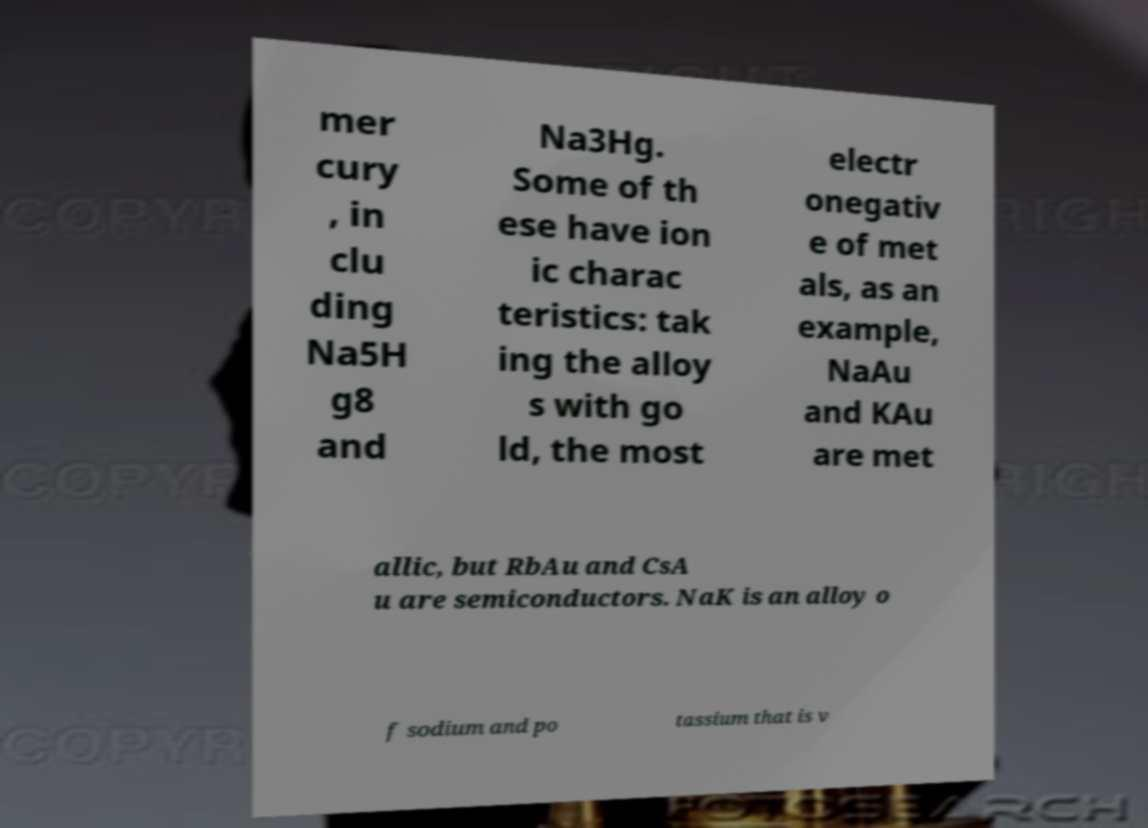Please read and relay the text visible in this image. What does it say? mer cury , in clu ding Na5H g8 and Na3Hg. Some of th ese have ion ic charac teristics: tak ing the alloy s with go ld, the most electr onegativ e of met als, as an example, NaAu and KAu are met allic, but RbAu and CsA u are semiconductors. NaK is an alloy o f sodium and po tassium that is v 